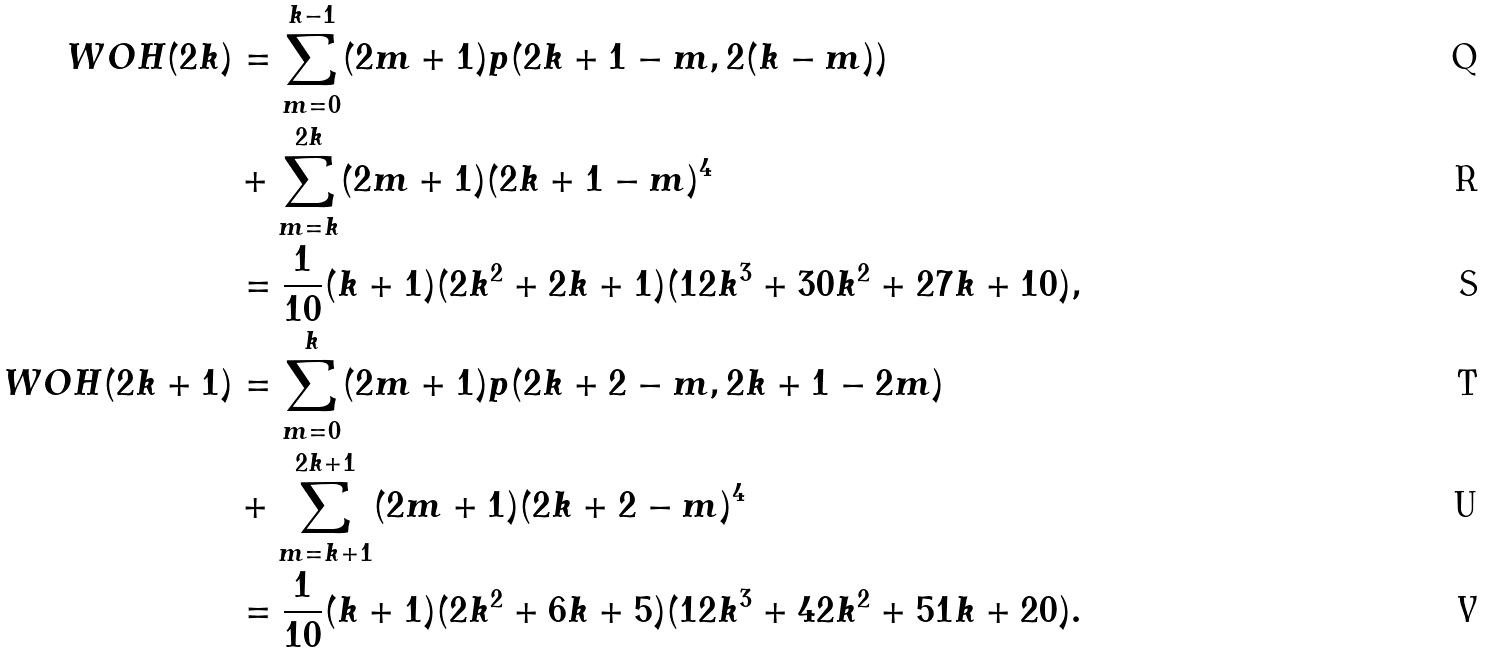Convert formula to latex. <formula><loc_0><loc_0><loc_500><loc_500>W O H ( 2 k ) & = \sum _ { m = 0 } ^ { k - 1 } ( 2 m + 1 ) p ( 2 k + 1 - m , 2 ( k - m ) ) \\ & + \sum _ { m = k } ^ { 2 k } ( 2 m + 1 ) ( 2 k + 1 - m ) ^ { 4 } \\ & = \frac { 1 } { 1 0 } ( k + 1 ) ( 2 k ^ { 2 } + 2 k + 1 ) ( 1 2 k ^ { 3 } + 3 0 k ^ { 2 } + 2 7 k + 1 0 ) , \\ W O H ( 2 k + 1 ) & = \sum _ { m = 0 } ^ { k } ( 2 m + 1 ) p ( 2 k + 2 - m , 2 k + 1 - 2 m ) \\ & + \sum _ { m = k + 1 } ^ { 2 k + 1 } ( 2 m + 1 ) ( 2 k + 2 - m ) ^ { 4 } \\ & = \frac { 1 } { 1 0 } ( k + 1 ) ( 2 k ^ { 2 } + 6 k + 5 ) ( 1 2 k ^ { 3 } + 4 2 k ^ { 2 } + 5 1 k + 2 0 ) .</formula> 